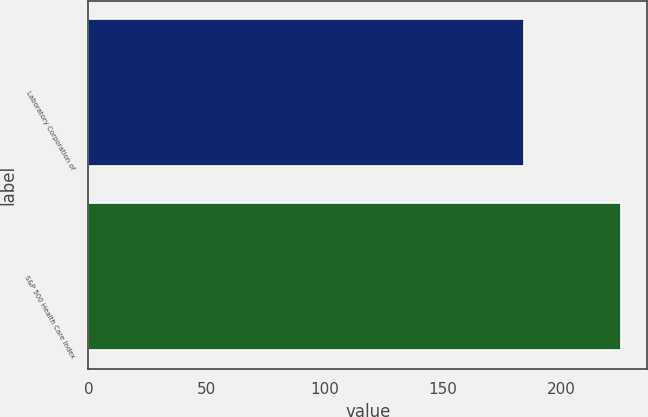<chart> <loc_0><loc_0><loc_500><loc_500><bar_chart><fcel>Laboratory Corporation of<fcel>S&P 500 Health Care Index<nl><fcel>184.15<fcel>225.13<nl></chart> 